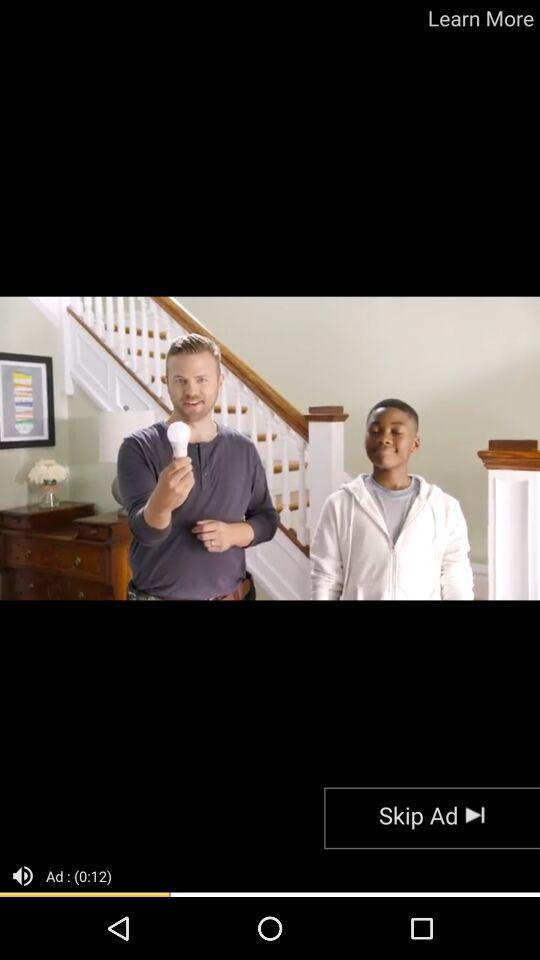How many seconds long is the ad?
Answer the question using a single word or phrase. 12 